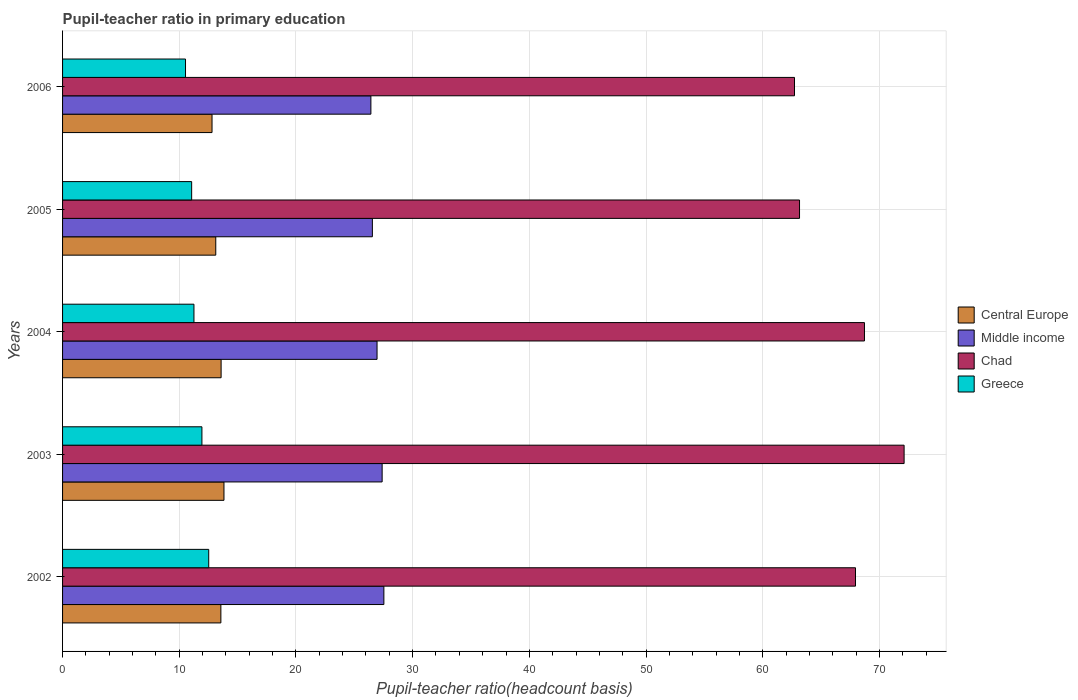How many groups of bars are there?
Make the answer very short. 5. Are the number of bars per tick equal to the number of legend labels?
Ensure brevity in your answer.  Yes. Are the number of bars on each tick of the Y-axis equal?
Offer a very short reply. Yes. How many bars are there on the 1st tick from the bottom?
Your response must be concise. 4. What is the label of the 2nd group of bars from the top?
Your answer should be compact. 2005. In how many cases, is the number of bars for a given year not equal to the number of legend labels?
Provide a short and direct response. 0. What is the pupil-teacher ratio in primary education in Central Europe in 2004?
Provide a succinct answer. 13.59. Across all years, what is the maximum pupil-teacher ratio in primary education in Chad?
Give a very brief answer. 72.12. Across all years, what is the minimum pupil-teacher ratio in primary education in Greece?
Your answer should be very brief. 10.54. In which year was the pupil-teacher ratio in primary education in Chad maximum?
Provide a succinct answer. 2003. In which year was the pupil-teacher ratio in primary education in Greece minimum?
Give a very brief answer. 2006. What is the total pupil-teacher ratio in primary education in Chad in the graph?
Ensure brevity in your answer.  334.66. What is the difference between the pupil-teacher ratio in primary education in Middle income in 2002 and that in 2006?
Offer a very short reply. 1.11. What is the difference between the pupil-teacher ratio in primary education in Central Europe in 2004 and the pupil-teacher ratio in primary education in Greece in 2003?
Offer a terse response. 1.64. What is the average pupil-teacher ratio in primary education in Central Europe per year?
Provide a succinct answer. 13.38. In the year 2005, what is the difference between the pupil-teacher ratio in primary education in Chad and pupil-teacher ratio in primary education in Central Europe?
Give a very brief answer. 50.03. What is the ratio of the pupil-teacher ratio in primary education in Middle income in 2003 to that in 2006?
Your response must be concise. 1.04. What is the difference between the highest and the second highest pupil-teacher ratio in primary education in Middle income?
Offer a very short reply. 0.15. What is the difference between the highest and the lowest pupil-teacher ratio in primary education in Greece?
Your answer should be very brief. 1.99. Is the sum of the pupil-teacher ratio in primary education in Central Europe in 2002 and 2005 greater than the maximum pupil-teacher ratio in primary education in Chad across all years?
Your answer should be very brief. No. What does the 2nd bar from the top in 2004 represents?
Offer a very short reply. Chad. Is it the case that in every year, the sum of the pupil-teacher ratio in primary education in Chad and pupil-teacher ratio in primary education in Middle income is greater than the pupil-teacher ratio in primary education in Central Europe?
Keep it short and to the point. Yes. What is the difference between two consecutive major ticks on the X-axis?
Your answer should be very brief. 10. Are the values on the major ticks of X-axis written in scientific E-notation?
Offer a terse response. No. Does the graph contain grids?
Your answer should be compact. Yes. What is the title of the graph?
Your response must be concise. Pupil-teacher ratio in primary education. Does "Madagascar" appear as one of the legend labels in the graph?
Make the answer very short. No. What is the label or title of the X-axis?
Offer a terse response. Pupil-teacher ratio(headcount basis). What is the label or title of the Y-axis?
Your response must be concise. Years. What is the Pupil-teacher ratio(headcount basis) of Central Europe in 2002?
Ensure brevity in your answer.  13.57. What is the Pupil-teacher ratio(headcount basis) in Middle income in 2002?
Provide a short and direct response. 27.53. What is the Pupil-teacher ratio(headcount basis) in Chad in 2002?
Keep it short and to the point. 67.95. What is the Pupil-teacher ratio(headcount basis) in Greece in 2002?
Your answer should be very brief. 12.52. What is the Pupil-teacher ratio(headcount basis) in Central Europe in 2003?
Provide a succinct answer. 13.83. What is the Pupil-teacher ratio(headcount basis) in Middle income in 2003?
Your answer should be compact. 27.39. What is the Pupil-teacher ratio(headcount basis) in Chad in 2003?
Offer a terse response. 72.12. What is the Pupil-teacher ratio(headcount basis) in Greece in 2003?
Offer a very short reply. 11.94. What is the Pupil-teacher ratio(headcount basis) of Central Europe in 2004?
Offer a very short reply. 13.59. What is the Pupil-teacher ratio(headcount basis) in Middle income in 2004?
Your response must be concise. 26.95. What is the Pupil-teacher ratio(headcount basis) of Chad in 2004?
Ensure brevity in your answer.  68.72. What is the Pupil-teacher ratio(headcount basis) of Greece in 2004?
Offer a very short reply. 11.26. What is the Pupil-teacher ratio(headcount basis) in Central Europe in 2005?
Keep it short and to the point. 13.13. What is the Pupil-teacher ratio(headcount basis) in Middle income in 2005?
Your response must be concise. 26.55. What is the Pupil-teacher ratio(headcount basis) of Chad in 2005?
Offer a very short reply. 63.15. What is the Pupil-teacher ratio(headcount basis) of Greece in 2005?
Ensure brevity in your answer.  11.06. What is the Pupil-teacher ratio(headcount basis) in Central Europe in 2006?
Your response must be concise. 12.81. What is the Pupil-teacher ratio(headcount basis) in Middle income in 2006?
Offer a very short reply. 26.42. What is the Pupil-teacher ratio(headcount basis) of Chad in 2006?
Provide a succinct answer. 62.72. What is the Pupil-teacher ratio(headcount basis) in Greece in 2006?
Offer a very short reply. 10.54. Across all years, what is the maximum Pupil-teacher ratio(headcount basis) of Central Europe?
Keep it short and to the point. 13.83. Across all years, what is the maximum Pupil-teacher ratio(headcount basis) in Middle income?
Provide a short and direct response. 27.53. Across all years, what is the maximum Pupil-teacher ratio(headcount basis) of Chad?
Provide a short and direct response. 72.12. Across all years, what is the maximum Pupil-teacher ratio(headcount basis) of Greece?
Your response must be concise. 12.52. Across all years, what is the minimum Pupil-teacher ratio(headcount basis) of Central Europe?
Your response must be concise. 12.81. Across all years, what is the minimum Pupil-teacher ratio(headcount basis) in Middle income?
Your answer should be compact. 26.42. Across all years, what is the minimum Pupil-teacher ratio(headcount basis) of Chad?
Your answer should be compact. 62.72. Across all years, what is the minimum Pupil-teacher ratio(headcount basis) of Greece?
Ensure brevity in your answer.  10.54. What is the total Pupil-teacher ratio(headcount basis) in Central Europe in the graph?
Your answer should be compact. 66.92. What is the total Pupil-teacher ratio(headcount basis) in Middle income in the graph?
Offer a terse response. 134.84. What is the total Pupil-teacher ratio(headcount basis) in Chad in the graph?
Give a very brief answer. 334.66. What is the total Pupil-teacher ratio(headcount basis) in Greece in the graph?
Your answer should be compact. 57.33. What is the difference between the Pupil-teacher ratio(headcount basis) in Central Europe in 2002 and that in 2003?
Make the answer very short. -0.27. What is the difference between the Pupil-teacher ratio(headcount basis) of Middle income in 2002 and that in 2003?
Ensure brevity in your answer.  0.15. What is the difference between the Pupil-teacher ratio(headcount basis) in Chad in 2002 and that in 2003?
Offer a very short reply. -4.16. What is the difference between the Pupil-teacher ratio(headcount basis) of Greece in 2002 and that in 2003?
Give a very brief answer. 0.58. What is the difference between the Pupil-teacher ratio(headcount basis) of Central Europe in 2002 and that in 2004?
Your answer should be very brief. -0.02. What is the difference between the Pupil-teacher ratio(headcount basis) of Middle income in 2002 and that in 2004?
Offer a very short reply. 0.59. What is the difference between the Pupil-teacher ratio(headcount basis) in Chad in 2002 and that in 2004?
Make the answer very short. -0.77. What is the difference between the Pupil-teacher ratio(headcount basis) of Greece in 2002 and that in 2004?
Your response must be concise. 1.27. What is the difference between the Pupil-teacher ratio(headcount basis) of Central Europe in 2002 and that in 2005?
Make the answer very short. 0.44. What is the difference between the Pupil-teacher ratio(headcount basis) of Middle income in 2002 and that in 2005?
Your response must be concise. 0.99. What is the difference between the Pupil-teacher ratio(headcount basis) of Chad in 2002 and that in 2005?
Make the answer very short. 4.8. What is the difference between the Pupil-teacher ratio(headcount basis) of Greece in 2002 and that in 2005?
Keep it short and to the point. 1.46. What is the difference between the Pupil-teacher ratio(headcount basis) in Central Europe in 2002 and that in 2006?
Provide a succinct answer. 0.76. What is the difference between the Pupil-teacher ratio(headcount basis) in Middle income in 2002 and that in 2006?
Provide a succinct answer. 1.11. What is the difference between the Pupil-teacher ratio(headcount basis) of Chad in 2002 and that in 2006?
Your answer should be very brief. 5.23. What is the difference between the Pupil-teacher ratio(headcount basis) of Greece in 2002 and that in 2006?
Your response must be concise. 1.99. What is the difference between the Pupil-teacher ratio(headcount basis) of Central Europe in 2003 and that in 2004?
Provide a succinct answer. 0.24. What is the difference between the Pupil-teacher ratio(headcount basis) of Middle income in 2003 and that in 2004?
Your answer should be compact. 0.44. What is the difference between the Pupil-teacher ratio(headcount basis) in Chad in 2003 and that in 2004?
Ensure brevity in your answer.  3.4. What is the difference between the Pupil-teacher ratio(headcount basis) of Greece in 2003 and that in 2004?
Provide a short and direct response. 0.68. What is the difference between the Pupil-teacher ratio(headcount basis) in Central Europe in 2003 and that in 2005?
Make the answer very short. 0.7. What is the difference between the Pupil-teacher ratio(headcount basis) in Middle income in 2003 and that in 2005?
Your answer should be compact. 0.84. What is the difference between the Pupil-teacher ratio(headcount basis) in Chad in 2003 and that in 2005?
Provide a short and direct response. 8.96. What is the difference between the Pupil-teacher ratio(headcount basis) in Greece in 2003 and that in 2005?
Provide a short and direct response. 0.88. What is the difference between the Pupil-teacher ratio(headcount basis) of Central Europe in 2003 and that in 2006?
Give a very brief answer. 1.02. What is the difference between the Pupil-teacher ratio(headcount basis) of Middle income in 2003 and that in 2006?
Your answer should be very brief. 0.96. What is the difference between the Pupil-teacher ratio(headcount basis) in Chad in 2003 and that in 2006?
Ensure brevity in your answer.  9.39. What is the difference between the Pupil-teacher ratio(headcount basis) in Greece in 2003 and that in 2006?
Offer a very short reply. 1.41. What is the difference between the Pupil-teacher ratio(headcount basis) in Central Europe in 2004 and that in 2005?
Keep it short and to the point. 0.46. What is the difference between the Pupil-teacher ratio(headcount basis) in Middle income in 2004 and that in 2005?
Offer a terse response. 0.4. What is the difference between the Pupil-teacher ratio(headcount basis) of Chad in 2004 and that in 2005?
Offer a very short reply. 5.56. What is the difference between the Pupil-teacher ratio(headcount basis) in Greece in 2004 and that in 2005?
Keep it short and to the point. 0.2. What is the difference between the Pupil-teacher ratio(headcount basis) in Central Europe in 2004 and that in 2006?
Your answer should be compact. 0.78. What is the difference between the Pupil-teacher ratio(headcount basis) in Middle income in 2004 and that in 2006?
Make the answer very short. 0.53. What is the difference between the Pupil-teacher ratio(headcount basis) in Chad in 2004 and that in 2006?
Offer a terse response. 6. What is the difference between the Pupil-teacher ratio(headcount basis) in Greece in 2004 and that in 2006?
Provide a succinct answer. 0.72. What is the difference between the Pupil-teacher ratio(headcount basis) of Central Europe in 2005 and that in 2006?
Offer a very short reply. 0.32. What is the difference between the Pupil-teacher ratio(headcount basis) of Middle income in 2005 and that in 2006?
Ensure brevity in your answer.  0.13. What is the difference between the Pupil-teacher ratio(headcount basis) of Chad in 2005 and that in 2006?
Your answer should be very brief. 0.43. What is the difference between the Pupil-teacher ratio(headcount basis) of Greece in 2005 and that in 2006?
Ensure brevity in your answer.  0.53. What is the difference between the Pupil-teacher ratio(headcount basis) of Central Europe in 2002 and the Pupil-teacher ratio(headcount basis) of Middle income in 2003?
Your response must be concise. -13.82. What is the difference between the Pupil-teacher ratio(headcount basis) of Central Europe in 2002 and the Pupil-teacher ratio(headcount basis) of Chad in 2003?
Your answer should be compact. -58.55. What is the difference between the Pupil-teacher ratio(headcount basis) of Central Europe in 2002 and the Pupil-teacher ratio(headcount basis) of Greece in 2003?
Your answer should be very brief. 1.62. What is the difference between the Pupil-teacher ratio(headcount basis) in Middle income in 2002 and the Pupil-teacher ratio(headcount basis) in Chad in 2003?
Give a very brief answer. -44.58. What is the difference between the Pupil-teacher ratio(headcount basis) of Middle income in 2002 and the Pupil-teacher ratio(headcount basis) of Greece in 2003?
Provide a short and direct response. 15.59. What is the difference between the Pupil-teacher ratio(headcount basis) of Chad in 2002 and the Pupil-teacher ratio(headcount basis) of Greece in 2003?
Offer a very short reply. 56.01. What is the difference between the Pupil-teacher ratio(headcount basis) of Central Europe in 2002 and the Pupil-teacher ratio(headcount basis) of Middle income in 2004?
Your response must be concise. -13.38. What is the difference between the Pupil-teacher ratio(headcount basis) in Central Europe in 2002 and the Pupil-teacher ratio(headcount basis) in Chad in 2004?
Make the answer very short. -55.15. What is the difference between the Pupil-teacher ratio(headcount basis) of Central Europe in 2002 and the Pupil-teacher ratio(headcount basis) of Greece in 2004?
Your response must be concise. 2.31. What is the difference between the Pupil-teacher ratio(headcount basis) in Middle income in 2002 and the Pupil-teacher ratio(headcount basis) in Chad in 2004?
Provide a short and direct response. -41.18. What is the difference between the Pupil-teacher ratio(headcount basis) of Middle income in 2002 and the Pupil-teacher ratio(headcount basis) of Greece in 2004?
Offer a terse response. 16.28. What is the difference between the Pupil-teacher ratio(headcount basis) in Chad in 2002 and the Pupil-teacher ratio(headcount basis) in Greece in 2004?
Offer a very short reply. 56.69. What is the difference between the Pupil-teacher ratio(headcount basis) in Central Europe in 2002 and the Pupil-teacher ratio(headcount basis) in Middle income in 2005?
Your response must be concise. -12.98. What is the difference between the Pupil-teacher ratio(headcount basis) of Central Europe in 2002 and the Pupil-teacher ratio(headcount basis) of Chad in 2005?
Keep it short and to the point. -49.59. What is the difference between the Pupil-teacher ratio(headcount basis) of Central Europe in 2002 and the Pupil-teacher ratio(headcount basis) of Greece in 2005?
Provide a succinct answer. 2.5. What is the difference between the Pupil-teacher ratio(headcount basis) in Middle income in 2002 and the Pupil-teacher ratio(headcount basis) in Chad in 2005?
Ensure brevity in your answer.  -35.62. What is the difference between the Pupil-teacher ratio(headcount basis) of Middle income in 2002 and the Pupil-teacher ratio(headcount basis) of Greece in 2005?
Keep it short and to the point. 16.47. What is the difference between the Pupil-teacher ratio(headcount basis) in Chad in 2002 and the Pupil-teacher ratio(headcount basis) in Greece in 2005?
Provide a short and direct response. 56.89. What is the difference between the Pupil-teacher ratio(headcount basis) in Central Europe in 2002 and the Pupil-teacher ratio(headcount basis) in Middle income in 2006?
Give a very brief answer. -12.86. What is the difference between the Pupil-teacher ratio(headcount basis) in Central Europe in 2002 and the Pupil-teacher ratio(headcount basis) in Chad in 2006?
Your answer should be very brief. -49.16. What is the difference between the Pupil-teacher ratio(headcount basis) in Central Europe in 2002 and the Pupil-teacher ratio(headcount basis) in Greece in 2006?
Offer a terse response. 3.03. What is the difference between the Pupil-teacher ratio(headcount basis) of Middle income in 2002 and the Pupil-teacher ratio(headcount basis) of Chad in 2006?
Give a very brief answer. -35.19. What is the difference between the Pupil-teacher ratio(headcount basis) in Middle income in 2002 and the Pupil-teacher ratio(headcount basis) in Greece in 2006?
Provide a succinct answer. 17. What is the difference between the Pupil-teacher ratio(headcount basis) in Chad in 2002 and the Pupil-teacher ratio(headcount basis) in Greece in 2006?
Keep it short and to the point. 57.42. What is the difference between the Pupil-teacher ratio(headcount basis) of Central Europe in 2003 and the Pupil-teacher ratio(headcount basis) of Middle income in 2004?
Ensure brevity in your answer.  -13.12. What is the difference between the Pupil-teacher ratio(headcount basis) in Central Europe in 2003 and the Pupil-teacher ratio(headcount basis) in Chad in 2004?
Provide a succinct answer. -54.89. What is the difference between the Pupil-teacher ratio(headcount basis) in Central Europe in 2003 and the Pupil-teacher ratio(headcount basis) in Greece in 2004?
Provide a short and direct response. 2.57. What is the difference between the Pupil-teacher ratio(headcount basis) in Middle income in 2003 and the Pupil-teacher ratio(headcount basis) in Chad in 2004?
Your answer should be very brief. -41.33. What is the difference between the Pupil-teacher ratio(headcount basis) in Middle income in 2003 and the Pupil-teacher ratio(headcount basis) in Greece in 2004?
Your response must be concise. 16.13. What is the difference between the Pupil-teacher ratio(headcount basis) in Chad in 2003 and the Pupil-teacher ratio(headcount basis) in Greece in 2004?
Offer a very short reply. 60.86. What is the difference between the Pupil-teacher ratio(headcount basis) in Central Europe in 2003 and the Pupil-teacher ratio(headcount basis) in Middle income in 2005?
Your response must be concise. -12.72. What is the difference between the Pupil-teacher ratio(headcount basis) of Central Europe in 2003 and the Pupil-teacher ratio(headcount basis) of Chad in 2005?
Your answer should be compact. -49.32. What is the difference between the Pupil-teacher ratio(headcount basis) in Central Europe in 2003 and the Pupil-teacher ratio(headcount basis) in Greece in 2005?
Your response must be concise. 2.77. What is the difference between the Pupil-teacher ratio(headcount basis) of Middle income in 2003 and the Pupil-teacher ratio(headcount basis) of Chad in 2005?
Your answer should be very brief. -35.77. What is the difference between the Pupil-teacher ratio(headcount basis) in Middle income in 2003 and the Pupil-teacher ratio(headcount basis) in Greece in 2005?
Offer a terse response. 16.32. What is the difference between the Pupil-teacher ratio(headcount basis) of Chad in 2003 and the Pupil-teacher ratio(headcount basis) of Greece in 2005?
Offer a terse response. 61.05. What is the difference between the Pupil-teacher ratio(headcount basis) of Central Europe in 2003 and the Pupil-teacher ratio(headcount basis) of Middle income in 2006?
Provide a succinct answer. -12.59. What is the difference between the Pupil-teacher ratio(headcount basis) in Central Europe in 2003 and the Pupil-teacher ratio(headcount basis) in Chad in 2006?
Offer a terse response. -48.89. What is the difference between the Pupil-teacher ratio(headcount basis) in Central Europe in 2003 and the Pupil-teacher ratio(headcount basis) in Greece in 2006?
Offer a terse response. 3.3. What is the difference between the Pupil-teacher ratio(headcount basis) in Middle income in 2003 and the Pupil-teacher ratio(headcount basis) in Chad in 2006?
Offer a very short reply. -35.34. What is the difference between the Pupil-teacher ratio(headcount basis) in Middle income in 2003 and the Pupil-teacher ratio(headcount basis) in Greece in 2006?
Keep it short and to the point. 16.85. What is the difference between the Pupil-teacher ratio(headcount basis) in Chad in 2003 and the Pupil-teacher ratio(headcount basis) in Greece in 2006?
Offer a terse response. 61.58. What is the difference between the Pupil-teacher ratio(headcount basis) in Central Europe in 2004 and the Pupil-teacher ratio(headcount basis) in Middle income in 2005?
Ensure brevity in your answer.  -12.96. What is the difference between the Pupil-teacher ratio(headcount basis) in Central Europe in 2004 and the Pupil-teacher ratio(headcount basis) in Chad in 2005?
Offer a very short reply. -49.57. What is the difference between the Pupil-teacher ratio(headcount basis) of Central Europe in 2004 and the Pupil-teacher ratio(headcount basis) of Greece in 2005?
Offer a terse response. 2.52. What is the difference between the Pupil-teacher ratio(headcount basis) in Middle income in 2004 and the Pupil-teacher ratio(headcount basis) in Chad in 2005?
Keep it short and to the point. -36.2. What is the difference between the Pupil-teacher ratio(headcount basis) in Middle income in 2004 and the Pupil-teacher ratio(headcount basis) in Greece in 2005?
Provide a succinct answer. 15.89. What is the difference between the Pupil-teacher ratio(headcount basis) in Chad in 2004 and the Pupil-teacher ratio(headcount basis) in Greece in 2005?
Offer a very short reply. 57.66. What is the difference between the Pupil-teacher ratio(headcount basis) in Central Europe in 2004 and the Pupil-teacher ratio(headcount basis) in Middle income in 2006?
Provide a succinct answer. -12.83. What is the difference between the Pupil-teacher ratio(headcount basis) of Central Europe in 2004 and the Pupil-teacher ratio(headcount basis) of Chad in 2006?
Offer a very short reply. -49.14. What is the difference between the Pupil-teacher ratio(headcount basis) of Central Europe in 2004 and the Pupil-teacher ratio(headcount basis) of Greece in 2006?
Offer a very short reply. 3.05. What is the difference between the Pupil-teacher ratio(headcount basis) of Middle income in 2004 and the Pupil-teacher ratio(headcount basis) of Chad in 2006?
Your answer should be compact. -35.77. What is the difference between the Pupil-teacher ratio(headcount basis) of Middle income in 2004 and the Pupil-teacher ratio(headcount basis) of Greece in 2006?
Provide a short and direct response. 16.41. What is the difference between the Pupil-teacher ratio(headcount basis) of Chad in 2004 and the Pupil-teacher ratio(headcount basis) of Greece in 2006?
Your answer should be very brief. 58.18. What is the difference between the Pupil-teacher ratio(headcount basis) in Central Europe in 2005 and the Pupil-teacher ratio(headcount basis) in Middle income in 2006?
Provide a succinct answer. -13.29. What is the difference between the Pupil-teacher ratio(headcount basis) of Central Europe in 2005 and the Pupil-teacher ratio(headcount basis) of Chad in 2006?
Make the answer very short. -49.59. What is the difference between the Pupil-teacher ratio(headcount basis) in Central Europe in 2005 and the Pupil-teacher ratio(headcount basis) in Greece in 2006?
Your response must be concise. 2.59. What is the difference between the Pupil-teacher ratio(headcount basis) of Middle income in 2005 and the Pupil-teacher ratio(headcount basis) of Chad in 2006?
Ensure brevity in your answer.  -36.17. What is the difference between the Pupil-teacher ratio(headcount basis) in Middle income in 2005 and the Pupil-teacher ratio(headcount basis) in Greece in 2006?
Give a very brief answer. 16.01. What is the difference between the Pupil-teacher ratio(headcount basis) in Chad in 2005 and the Pupil-teacher ratio(headcount basis) in Greece in 2006?
Make the answer very short. 52.62. What is the average Pupil-teacher ratio(headcount basis) of Central Europe per year?
Give a very brief answer. 13.38. What is the average Pupil-teacher ratio(headcount basis) of Middle income per year?
Your answer should be very brief. 26.97. What is the average Pupil-teacher ratio(headcount basis) in Chad per year?
Give a very brief answer. 66.93. What is the average Pupil-teacher ratio(headcount basis) in Greece per year?
Your answer should be very brief. 11.46. In the year 2002, what is the difference between the Pupil-teacher ratio(headcount basis) of Central Europe and Pupil-teacher ratio(headcount basis) of Middle income?
Offer a terse response. -13.97. In the year 2002, what is the difference between the Pupil-teacher ratio(headcount basis) in Central Europe and Pupil-teacher ratio(headcount basis) in Chad?
Keep it short and to the point. -54.39. In the year 2002, what is the difference between the Pupil-teacher ratio(headcount basis) in Central Europe and Pupil-teacher ratio(headcount basis) in Greece?
Ensure brevity in your answer.  1.04. In the year 2002, what is the difference between the Pupil-teacher ratio(headcount basis) in Middle income and Pupil-teacher ratio(headcount basis) in Chad?
Offer a terse response. -40.42. In the year 2002, what is the difference between the Pupil-teacher ratio(headcount basis) of Middle income and Pupil-teacher ratio(headcount basis) of Greece?
Keep it short and to the point. 15.01. In the year 2002, what is the difference between the Pupil-teacher ratio(headcount basis) in Chad and Pupil-teacher ratio(headcount basis) in Greece?
Your response must be concise. 55.43. In the year 2003, what is the difference between the Pupil-teacher ratio(headcount basis) of Central Europe and Pupil-teacher ratio(headcount basis) of Middle income?
Your answer should be very brief. -13.56. In the year 2003, what is the difference between the Pupil-teacher ratio(headcount basis) of Central Europe and Pupil-teacher ratio(headcount basis) of Chad?
Your answer should be very brief. -58.28. In the year 2003, what is the difference between the Pupil-teacher ratio(headcount basis) of Central Europe and Pupil-teacher ratio(headcount basis) of Greece?
Ensure brevity in your answer.  1.89. In the year 2003, what is the difference between the Pupil-teacher ratio(headcount basis) in Middle income and Pupil-teacher ratio(headcount basis) in Chad?
Offer a very short reply. -44.73. In the year 2003, what is the difference between the Pupil-teacher ratio(headcount basis) of Middle income and Pupil-teacher ratio(headcount basis) of Greece?
Offer a terse response. 15.44. In the year 2003, what is the difference between the Pupil-teacher ratio(headcount basis) in Chad and Pupil-teacher ratio(headcount basis) in Greece?
Provide a succinct answer. 60.17. In the year 2004, what is the difference between the Pupil-teacher ratio(headcount basis) in Central Europe and Pupil-teacher ratio(headcount basis) in Middle income?
Your response must be concise. -13.36. In the year 2004, what is the difference between the Pupil-teacher ratio(headcount basis) in Central Europe and Pupil-teacher ratio(headcount basis) in Chad?
Give a very brief answer. -55.13. In the year 2004, what is the difference between the Pupil-teacher ratio(headcount basis) of Central Europe and Pupil-teacher ratio(headcount basis) of Greece?
Ensure brevity in your answer.  2.33. In the year 2004, what is the difference between the Pupil-teacher ratio(headcount basis) of Middle income and Pupil-teacher ratio(headcount basis) of Chad?
Give a very brief answer. -41.77. In the year 2004, what is the difference between the Pupil-teacher ratio(headcount basis) of Middle income and Pupil-teacher ratio(headcount basis) of Greece?
Keep it short and to the point. 15.69. In the year 2004, what is the difference between the Pupil-teacher ratio(headcount basis) of Chad and Pupil-teacher ratio(headcount basis) of Greece?
Your answer should be compact. 57.46. In the year 2005, what is the difference between the Pupil-teacher ratio(headcount basis) of Central Europe and Pupil-teacher ratio(headcount basis) of Middle income?
Your response must be concise. -13.42. In the year 2005, what is the difference between the Pupil-teacher ratio(headcount basis) of Central Europe and Pupil-teacher ratio(headcount basis) of Chad?
Provide a short and direct response. -50.03. In the year 2005, what is the difference between the Pupil-teacher ratio(headcount basis) of Central Europe and Pupil-teacher ratio(headcount basis) of Greece?
Your response must be concise. 2.07. In the year 2005, what is the difference between the Pupil-teacher ratio(headcount basis) of Middle income and Pupil-teacher ratio(headcount basis) of Chad?
Offer a terse response. -36.61. In the year 2005, what is the difference between the Pupil-teacher ratio(headcount basis) of Middle income and Pupil-teacher ratio(headcount basis) of Greece?
Your answer should be very brief. 15.49. In the year 2005, what is the difference between the Pupil-teacher ratio(headcount basis) in Chad and Pupil-teacher ratio(headcount basis) in Greece?
Ensure brevity in your answer.  52.09. In the year 2006, what is the difference between the Pupil-teacher ratio(headcount basis) in Central Europe and Pupil-teacher ratio(headcount basis) in Middle income?
Give a very brief answer. -13.61. In the year 2006, what is the difference between the Pupil-teacher ratio(headcount basis) in Central Europe and Pupil-teacher ratio(headcount basis) in Chad?
Provide a succinct answer. -49.91. In the year 2006, what is the difference between the Pupil-teacher ratio(headcount basis) in Central Europe and Pupil-teacher ratio(headcount basis) in Greece?
Provide a short and direct response. 2.27. In the year 2006, what is the difference between the Pupil-teacher ratio(headcount basis) in Middle income and Pupil-teacher ratio(headcount basis) in Chad?
Offer a very short reply. -36.3. In the year 2006, what is the difference between the Pupil-teacher ratio(headcount basis) in Middle income and Pupil-teacher ratio(headcount basis) in Greece?
Give a very brief answer. 15.89. In the year 2006, what is the difference between the Pupil-teacher ratio(headcount basis) of Chad and Pupil-teacher ratio(headcount basis) of Greece?
Provide a short and direct response. 52.19. What is the ratio of the Pupil-teacher ratio(headcount basis) of Central Europe in 2002 to that in 2003?
Your answer should be compact. 0.98. What is the ratio of the Pupil-teacher ratio(headcount basis) in Middle income in 2002 to that in 2003?
Offer a terse response. 1.01. What is the ratio of the Pupil-teacher ratio(headcount basis) of Chad in 2002 to that in 2003?
Provide a short and direct response. 0.94. What is the ratio of the Pupil-teacher ratio(headcount basis) of Greece in 2002 to that in 2003?
Offer a terse response. 1.05. What is the ratio of the Pupil-teacher ratio(headcount basis) of Middle income in 2002 to that in 2004?
Provide a short and direct response. 1.02. What is the ratio of the Pupil-teacher ratio(headcount basis) in Greece in 2002 to that in 2004?
Make the answer very short. 1.11. What is the ratio of the Pupil-teacher ratio(headcount basis) of Central Europe in 2002 to that in 2005?
Ensure brevity in your answer.  1.03. What is the ratio of the Pupil-teacher ratio(headcount basis) in Middle income in 2002 to that in 2005?
Ensure brevity in your answer.  1.04. What is the ratio of the Pupil-teacher ratio(headcount basis) of Chad in 2002 to that in 2005?
Give a very brief answer. 1.08. What is the ratio of the Pupil-teacher ratio(headcount basis) in Greece in 2002 to that in 2005?
Your response must be concise. 1.13. What is the ratio of the Pupil-teacher ratio(headcount basis) in Central Europe in 2002 to that in 2006?
Provide a succinct answer. 1.06. What is the ratio of the Pupil-teacher ratio(headcount basis) in Middle income in 2002 to that in 2006?
Your answer should be compact. 1.04. What is the ratio of the Pupil-teacher ratio(headcount basis) in Chad in 2002 to that in 2006?
Provide a short and direct response. 1.08. What is the ratio of the Pupil-teacher ratio(headcount basis) of Greece in 2002 to that in 2006?
Provide a succinct answer. 1.19. What is the ratio of the Pupil-teacher ratio(headcount basis) of Central Europe in 2003 to that in 2004?
Keep it short and to the point. 1.02. What is the ratio of the Pupil-teacher ratio(headcount basis) in Middle income in 2003 to that in 2004?
Your answer should be compact. 1.02. What is the ratio of the Pupil-teacher ratio(headcount basis) in Chad in 2003 to that in 2004?
Give a very brief answer. 1.05. What is the ratio of the Pupil-teacher ratio(headcount basis) in Greece in 2003 to that in 2004?
Offer a very short reply. 1.06. What is the ratio of the Pupil-teacher ratio(headcount basis) of Central Europe in 2003 to that in 2005?
Offer a terse response. 1.05. What is the ratio of the Pupil-teacher ratio(headcount basis) of Middle income in 2003 to that in 2005?
Your response must be concise. 1.03. What is the ratio of the Pupil-teacher ratio(headcount basis) of Chad in 2003 to that in 2005?
Make the answer very short. 1.14. What is the ratio of the Pupil-teacher ratio(headcount basis) of Greece in 2003 to that in 2005?
Offer a terse response. 1.08. What is the ratio of the Pupil-teacher ratio(headcount basis) of Central Europe in 2003 to that in 2006?
Give a very brief answer. 1.08. What is the ratio of the Pupil-teacher ratio(headcount basis) of Middle income in 2003 to that in 2006?
Offer a very short reply. 1.04. What is the ratio of the Pupil-teacher ratio(headcount basis) in Chad in 2003 to that in 2006?
Ensure brevity in your answer.  1.15. What is the ratio of the Pupil-teacher ratio(headcount basis) of Greece in 2003 to that in 2006?
Provide a short and direct response. 1.13. What is the ratio of the Pupil-teacher ratio(headcount basis) of Central Europe in 2004 to that in 2005?
Make the answer very short. 1.03. What is the ratio of the Pupil-teacher ratio(headcount basis) in Middle income in 2004 to that in 2005?
Keep it short and to the point. 1.02. What is the ratio of the Pupil-teacher ratio(headcount basis) of Chad in 2004 to that in 2005?
Ensure brevity in your answer.  1.09. What is the ratio of the Pupil-teacher ratio(headcount basis) in Greece in 2004 to that in 2005?
Your answer should be very brief. 1.02. What is the ratio of the Pupil-teacher ratio(headcount basis) of Central Europe in 2004 to that in 2006?
Your answer should be very brief. 1.06. What is the ratio of the Pupil-teacher ratio(headcount basis) in Middle income in 2004 to that in 2006?
Offer a very short reply. 1.02. What is the ratio of the Pupil-teacher ratio(headcount basis) in Chad in 2004 to that in 2006?
Make the answer very short. 1.1. What is the ratio of the Pupil-teacher ratio(headcount basis) in Greece in 2004 to that in 2006?
Your response must be concise. 1.07. What is the ratio of the Pupil-teacher ratio(headcount basis) of Central Europe in 2005 to that in 2006?
Make the answer very short. 1.02. What is the ratio of the Pupil-teacher ratio(headcount basis) of Chad in 2005 to that in 2006?
Make the answer very short. 1.01. What is the ratio of the Pupil-teacher ratio(headcount basis) in Greece in 2005 to that in 2006?
Provide a succinct answer. 1.05. What is the difference between the highest and the second highest Pupil-teacher ratio(headcount basis) of Central Europe?
Your response must be concise. 0.24. What is the difference between the highest and the second highest Pupil-teacher ratio(headcount basis) of Middle income?
Make the answer very short. 0.15. What is the difference between the highest and the second highest Pupil-teacher ratio(headcount basis) in Chad?
Provide a short and direct response. 3.4. What is the difference between the highest and the second highest Pupil-teacher ratio(headcount basis) in Greece?
Offer a terse response. 0.58. What is the difference between the highest and the lowest Pupil-teacher ratio(headcount basis) in Central Europe?
Provide a short and direct response. 1.02. What is the difference between the highest and the lowest Pupil-teacher ratio(headcount basis) of Middle income?
Give a very brief answer. 1.11. What is the difference between the highest and the lowest Pupil-teacher ratio(headcount basis) in Chad?
Provide a short and direct response. 9.39. What is the difference between the highest and the lowest Pupil-teacher ratio(headcount basis) in Greece?
Keep it short and to the point. 1.99. 